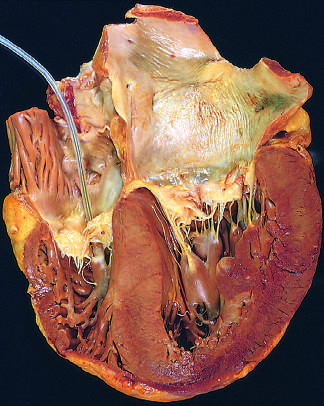re the left ventricle and left atrium shown on the right in this four-chamber view of the heart?
Answer the question using a single word or phrase. Yes 